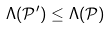Convert formula to latex. <formula><loc_0><loc_0><loc_500><loc_500>\Lambda ( \mathcal { P } ^ { \prime } ) \leq \Lambda ( \mathcal { P } )</formula> 